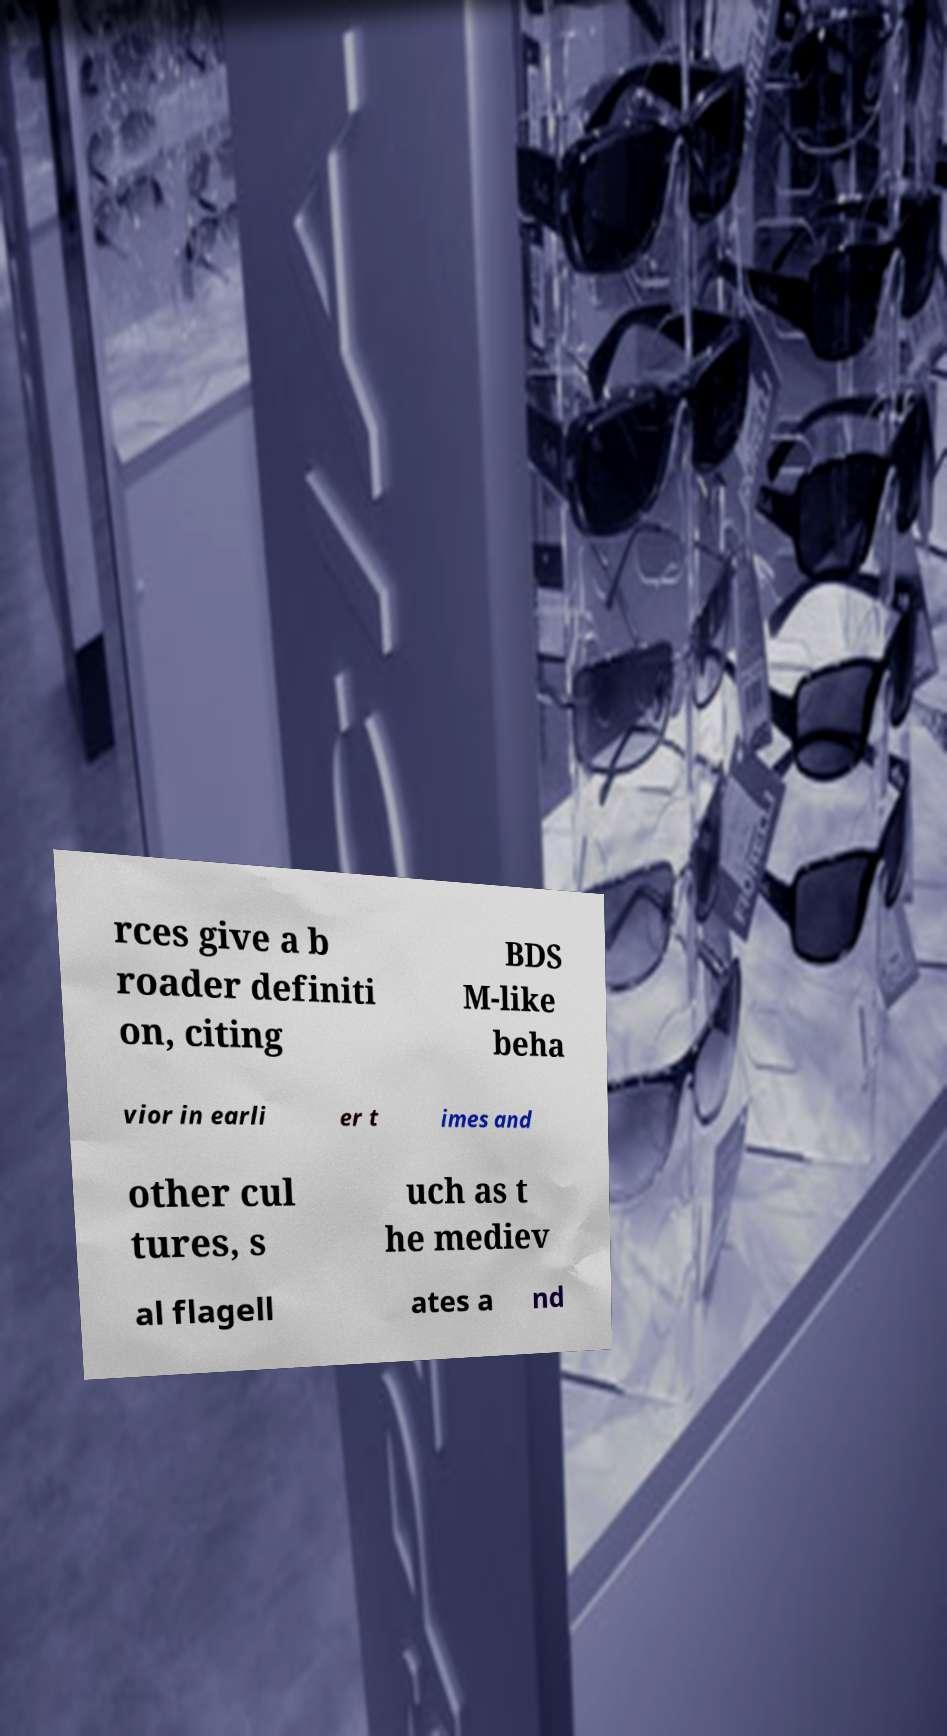Please read and relay the text visible in this image. What does it say? rces give a b roader definiti on, citing BDS M-like beha vior in earli er t imes and other cul tures, s uch as t he mediev al flagell ates a nd 